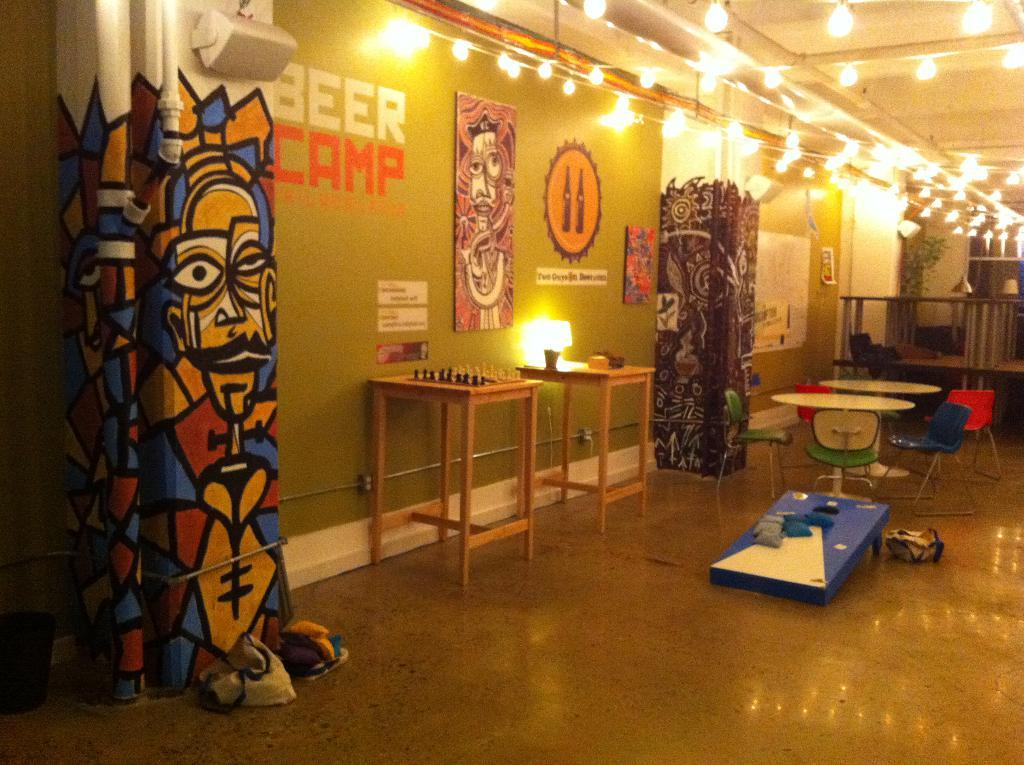<image>
Offer a succinct explanation of the picture presented. the inside of a building with a wall that says 'beer camp' on it 